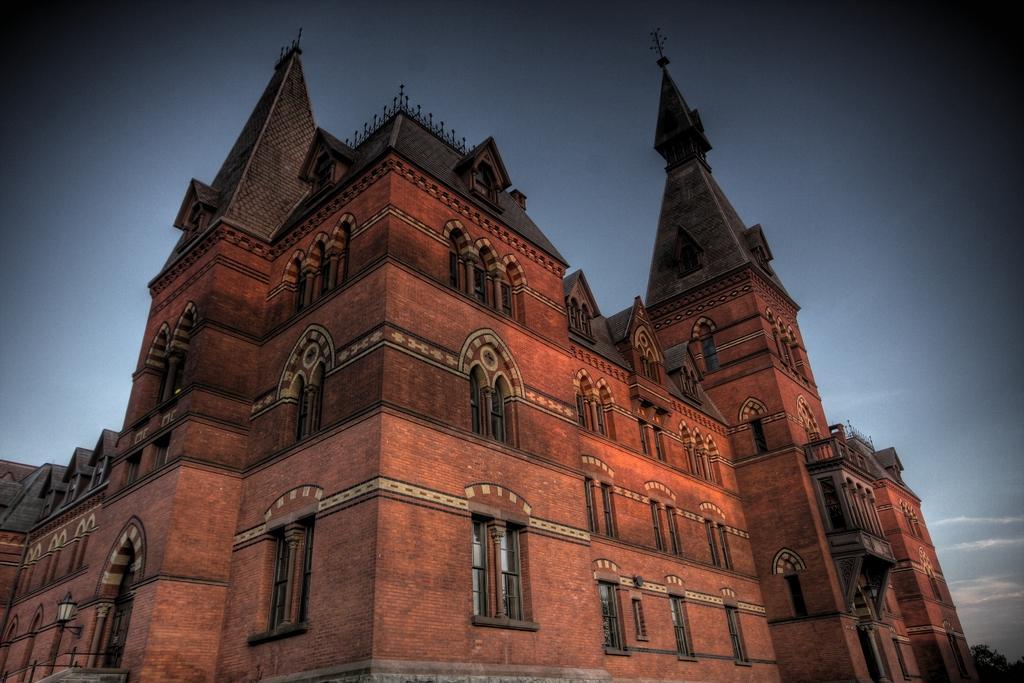Describe this image in one or two sentences. In this picture we can see a building, there is the sky at the top of the picture, we can see windows of this building, it looks like a tree at the right bottom. 